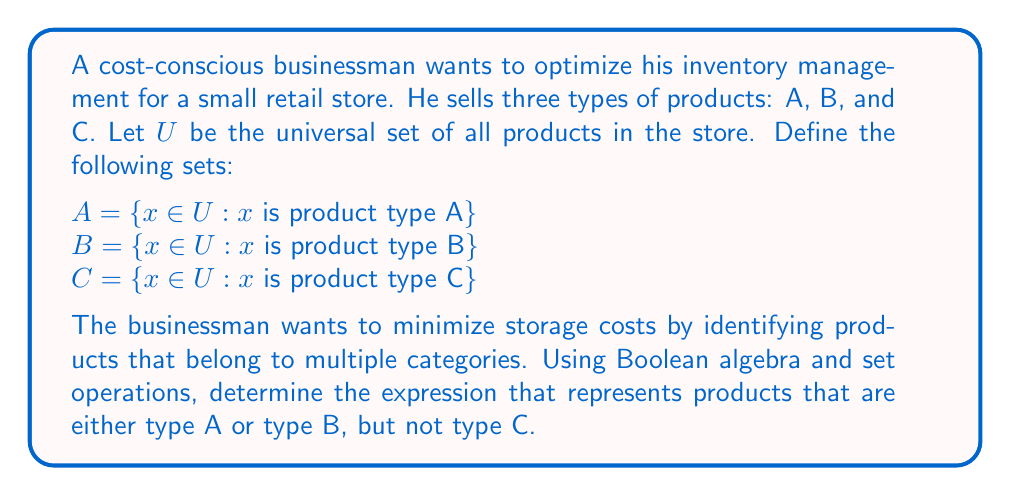What is the answer to this math problem? To solve this problem, we'll use Boolean algebra and set theory operations:

1. First, let's identify the set operations we need:
   - Union (OR): $A \cup B$
   - Complement (NOT): $C^c$

2. We want products that are either type A or type B, which is represented by $A \cup B$.

3. We also want products that are not type C, which is represented by $C^c$.

4. To combine these conditions, we need to find the intersection of $(A \cup B)$ and $C^c$.

5. Using the Boolean algebra expression:
   $$(A \cup B) \cap C^c$$

6. This can be further simplified using De Morgan's Laws:
   $$(A \cup B) \cap C^c = (A \cap C^c) \cup (B \cap C^c)$$

This final expression represents products that are either:
- Type A and not Type C, or
- Type B and not Type C

This optimization helps the businessman minimize storage costs by identifying products that fit multiple categories while excluding unwanted combinations.
Answer: $(A \cup B) \cap C^c$ or equivalently $(A \cap C^c) \cup (B \cap C^c)$ 